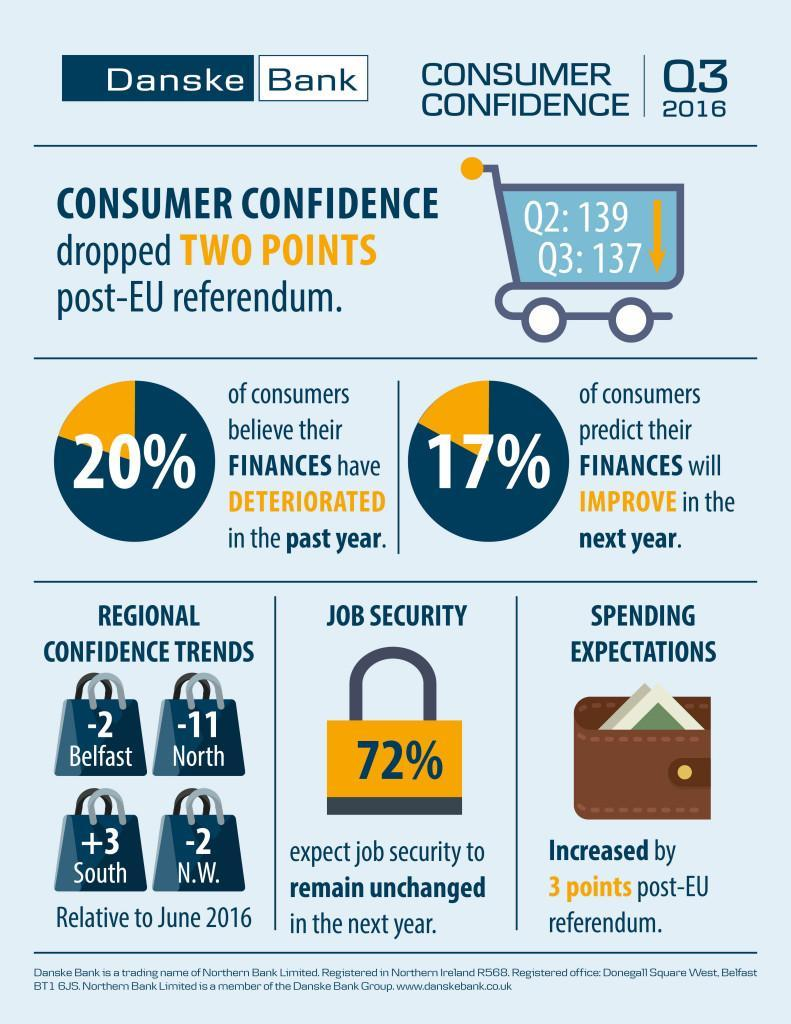In which region has the confidence trend been positive
Answer the question with a short phrase. South In which regions have the confidence trend by -2 Belfast, N.W. What has been the impact of post-EU referendum to consumer confidence dropped two points Which quarters were considered in the consumer confidence Q2, Q3 